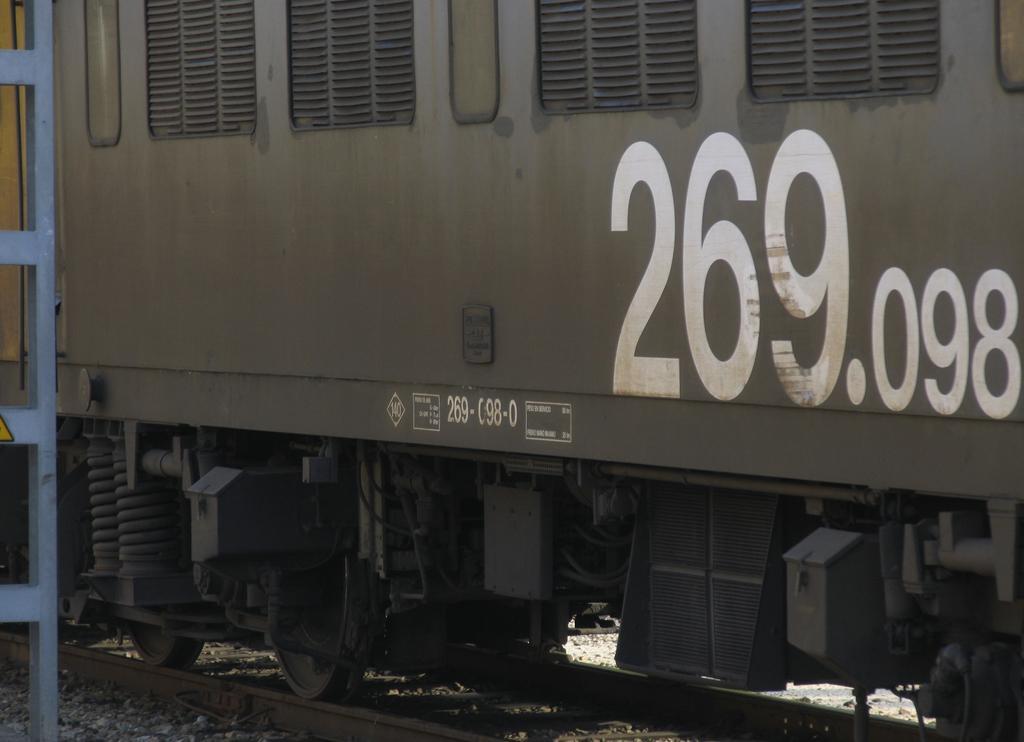Please provide a concise description of this image. In this image we can see a train on the train track with some text written on it and behind it we can see a pole. 